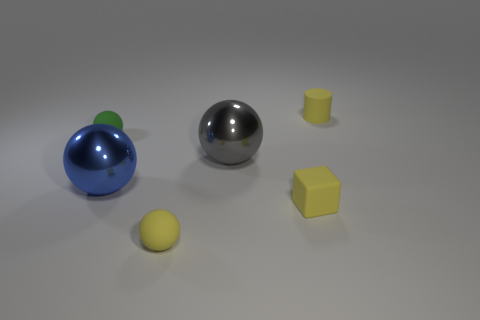Subtract 1 balls. How many balls are left? 3 Add 2 tiny green matte spheres. How many objects exist? 8 Subtract all cylinders. How many objects are left? 5 Add 4 green rubber cubes. How many green rubber cubes exist? 4 Subtract 0 green cubes. How many objects are left? 6 Subtract all small cyan matte objects. Subtract all yellow balls. How many objects are left? 5 Add 1 big blue shiny things. How many big blue shiny things are left? 2 